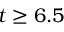<formula> <loc_0><loc_0><loc_500><loc_500>t \geq 6 . 5</formula> 